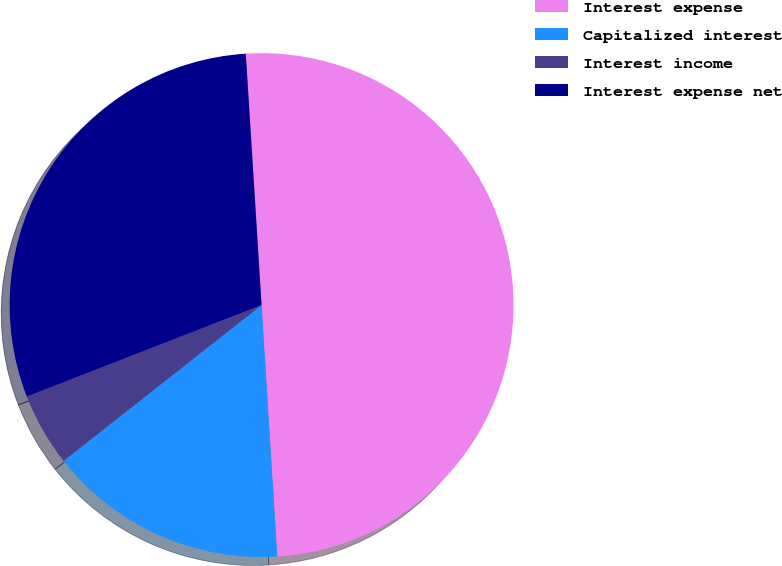<chart> <loc_0><loc_0><loc_500><loc_500><pie_chart><fcel>Interest expense<fcel>Capitalized interest<fcel>Interest income<fcel>Interest expense net<nl><fcel>50.0%<fcel>15.38%<fcel>4.7%<fcel>29.91%<nl></chart> 